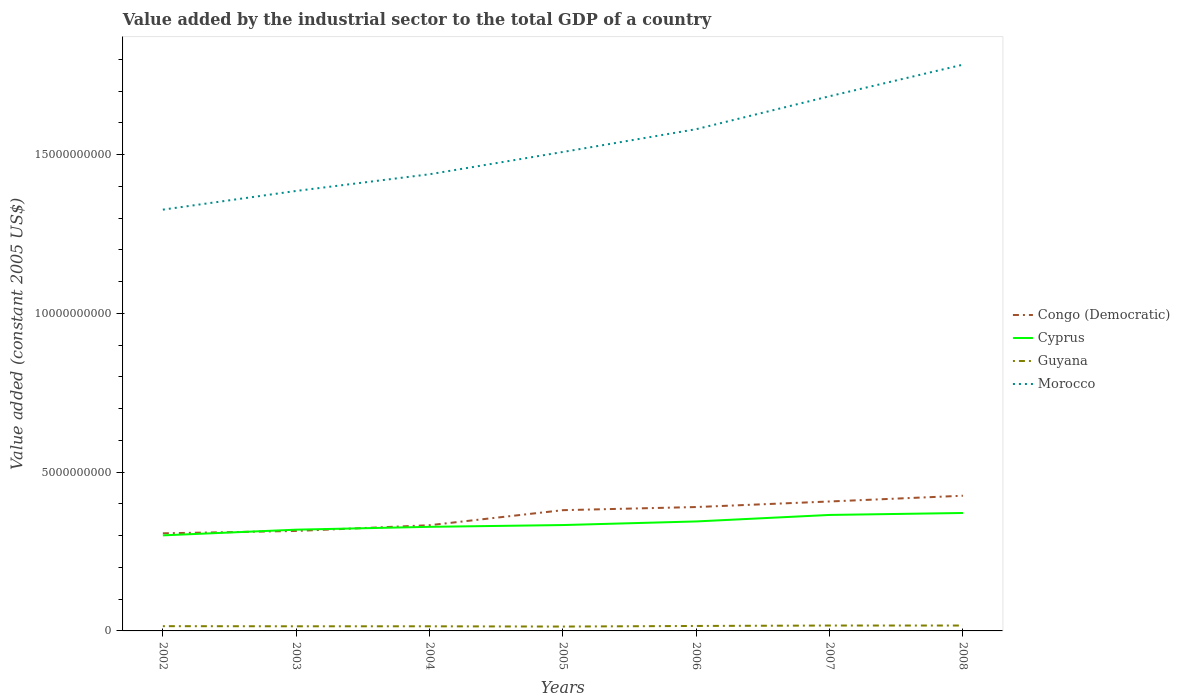How many different coloured lines are there?
Ensure brevity in your answer.  4. Across all years, what is the maximum value added by the industrial sector in Morocco?
Offer a very short reply. 1.33e+1. What is the total value added by the industrial sector in Cyprus in the graph?
Provide a short and direct response. -1.79e+08. What is the difference between the highest and the second highest value added by the industrial sector in Congo (Democratic)?
Offer a terse response. 1.18e+09. Is the value added by the industrial sector in Morocco strictly greater than the value added by the industrial sector in Congo (Democratic) over the years?
Offer a terse response. No. How many years are there in the graph?
Provide a succinct answer. 7. What is the difference between two consecutive major ticks on the Y-axis?
Provide a short and direct response. 5.00e+09. Does the graph contain any zero values?
Your response must be concise. No. Where does the legend appear in the graph?
Provide a succinct answer. Center right. What is the title of the graph?
Ensure brevity in your answer.  Value added by the industrial sector to the total GDP of a country. What is the label or title of the Y-axis?
Provide a succinct answer. Value added (constant 2005 US$). What is the Value added (constant 2005 US$) of Congo (Democratic) in 2002?
Offer a very short reply. 3.07e+09. What is the Value added (constant 2005 US$) in Cyprus in 2002?
Ensure brevity in your answer.  3.01e+09. What is the Value added (constant 2005 US$) of Guyana in 2002?
Your answer should be very brief. 1.50e+08. What is the Value added (constant 2005 US$) of Morocco in 2002?
Offer a very short reply. 1.33e+1. What is the Value added (constant 2005 US$) of Congo (Democratic) in 2003?
Your answer should be very brief. 3.15e+09. What is the Value added (constant 2005 US$) of Cyprus in 2003?
Your answer should be very brief. 3.19e+09. What is the Value added (constant 2005 US$) in Guyana in 2003?
Provide a short and direct response. 1.46e+08. What is the Value added (constant 2005 US$) of Morocco in 2003?
Provide a short and direct response. 1.39e+1. What is the Value added (constant 2005 US$) of Congo (Democratic) in 2004?
Provide a short and direct response. 3.33e+09. What is the Value added (constant 2005 US$) in Cyprus in 2004?
Provide a succinct answer. 3.28e+09. What is the Value added (constant 2005 US$) in Guyana in 2004?
Make the answer very short. 1.45e+08. What is the Value added (constant 2005 US$) of Morocco in 2004?
Provide a short and direct response. 1.44e+1. What is the Value added (constant 2005 US$) in Congo (Democratic) in 2005?
Offer a terse response. 3.80e+09. What is the Value added (constant 2005 US$) in Cyprus in 2005?
Keep it short and to the point. 3.34e+09. What is the Value added (constant 2005 US$) of Guyana in 2005?
Keep it short and to the point. 1.38e+08. What is the Value added (constant 2005 US$) in Morocco in 2005?
Ensure brevity in your answer.  1.51e+1. What is the Value added (constant 2005 US$) in Congo (Democratic) in 2006?
Provide a succinct answer. 3.90e+09. What is the Value added (constant 2005 US$) in Cyprus in 2006?
Your answer should be very brief. 3.45e+09. What is the Value added (constant 2005 US$) in Guyana in 2006?
Keep it short and to the point. 1.56e+08. What is the Value added (constant 2005 US$) of Morocco in 2006?
Offer a terse response. 1.58e+1. What is the Value added (constant 2005 US$) in Congo (Democratic) in 2007?
Offer a terse response. 4.08e+09. What is the Value added (constant 2005 US$) of Cyprus in 2007?
Offer a terse response. 3.65e+09. What is the Value added (constant 2005 US$) in Guyana in 2007?
Make the answer very short. 1.70e+08. What is the Value added (constant 2005 US$) of Morocco in 2007?
Your answer should be very brief. 1.68e+1. What is the Value added (constant 2005 US$) in Congo (Democratic) in 2008?
Make the answer very short. 4.26e+09. What is the Value added (constant 2005 US$) of Cyprus in 2008?
Give a very brief answer. 3.72e+09. What is the Value added (constant 2005 US$) of Guyana in 2008?
Provide a succinct answer. 1.70e+08. What is the Value added (constant 2005 US$) in Morocco in 2008?
Offer a terse response. 1.78e+1. Across all years, what is the maximum Value added (constant 2005 US$) of Congo (Democratic)?
Your answer should be very brief. 4.26e+09. Across all years, what is the maximum Value added (constant 2005 US$) in Cyprus?
Make the answer very short. 3.72e+09. Across all years, what is the maximum Value added (constant 2005 US$) of Guyana?
Keep it short and to the point. 1.70e+08. Across all years, what is the maximum Value added (constant 2005 US$) in Morocco?
Keep it short and to the point. 1.78e+1. Across all years, what is the minimum Value added (constant 2005 US$) in Congo (Democratic)?
Your response must be concise. 3.07e+09. Across all years, what is the minimum Value added (constant 2005 US$) of Cyprus?
Keep it short and to the point. 3.01e+09. Across all years, what is the minimum Value added (constant 2005 US$) of Guyana?
Your answer should be very brief. 1.38e+08. Across all years, what is the minimum Value added (constant 2005 US$) in Morocco?
Give a very brief answer. 1.33e+1. What is the total Value added (constant 2005 US$) in Congo (Democratic) in the graph?
Offer a terse response. 2.56e+1. What is the total Value added (constant 2005 US$) of Cyprus in the graph?
Provide a short and direct response. 2.36e+1. What is the total Value added (constant 2005 US$) in Guyana in the graph?
Provide a succinct answer. 1.07e+09. What is the total Value added (constant 2005 US$) of Morocco in the graph?
Offer a terse response. 1.07e+11. What is the difference between the Value added (constant 2005 US$) of Congo (Democratic) in 2002 and that in 2003?
Keep it short and to the point. -7.45e+07. What is the difference between the Value added (constant 2005 US$) of Cyprus in 2002 and that in 2003?
Keep it short and to the point. -1.79e+08. What is the difference between the Value added (constant 2005 US$) of Guyana in 2002 and that in 2003?
Give a very brief answer. 4.14e+06. What is the difference between the Value added (constant 2005 US$) of Morocco in 2002 and that in 2003?
Keep it short and to the point. -5.89e+08. What is the difference between the Value added (constant 2005 US$) of Congo (Democratic) in 2002 and that in 2004?
Your answer should be very brief. -2.56e+08. What is the difference between the Value added (constant 2005 US$) of Cyprus in 2002 and that in 2004?
Provide a short and direct response. -2.69e+08. What is the difference between the Value added (constant 2005 US$) in Guyana in 2002 and that in 2004?
Your response must be concise. 4.43e+06. What is the difference between the Value added (constant 2005 US$) in Morocco in 2002 and that in 2004?
Ensure brevity in your answer.  -1.11e+09. What is the difference between the Value added (constant 2005 US$) of Congo (Democratic) in 2002 and that in 2005?
Your answer should be very brief. -7.29e+08. What is the difference between the Value added (constant 2005 US$) of Cyprus in 2002 and that in 2005?
Your answer should be compact. -3.25e+08. What is the difference between the Value added (constant 2005 US$) of Guyana in 2002 and that in 2005?
Offer a very short reply. 1.24e+07. What is the difference between the Value added (constant 2005 US$) in Morocco in 2002 and that in 2005?
Your answer should be very brief. -1.82e+09. What is the difference between the Value added (constant 2005 US$) of Congo (Democratic) in 2002 and that in 2006?
Your answer should be compact. -8.28e+08. What is the difference between the Value added (constant 2005 US$) of Cyprus in 2002 and that in 2006?
Offer a terse response. -4.38e+08. What is the difference between the Value added (constant 2005 US$) in Guyana in 2002 and that in 2006?
Give a very brief answer. -6.51e+06. What is the difference between the Value added (constant 2005 US$) in Morocco in 2002 and that in 2006?
Provide a succinct answer. -2.53e+09. What is the difference between the Value added (constant 2005 US$) in Congo (Democratic) in 2002 and that in 2007?
Your answer should be compact. -1.00e+09. What is the difference between the Value added (constant 2005 US$) in Cyprus in 2002 and that in 2007?
Keep it short and to the point. -6.43e+08. What is the difference between the Value added (constant 2005 US$) in Guyana in 2002 and that in 2007?
Provide a short and direct response. -1.97e+07. What is the difference between the Value added (constant 2005 US$) in Morocco in 2002 and that in 2007?
Ensure brevity in your answer.  -3.57e+09. What is the difference between the Value added (constant 2005 US$) of Congo (Democratic) in 2002 and that in 2008?
Make the answer very short. -1.18e+09. What is the difference between the Value added (constant 2005 US$) of Cyprus in 2002 and that in 2008?
Your answer should be very brief. -7.05e+08. What is the difference between the Value added (constant 2005 US$) of Guyana in 2002 and that in 2008?
Provide a succinct answer. -2.00e+07. What is the difference between the Value added (constant 2005 US$) of Morocco in 2002 and that in 2008?
Make the answer very short. -4.57e+09. What is the difference between the Value added (constant 2005 US$) in Congo (Democratic) in 2003 and that in 2004?
Provide a short and direct response. -1.81e+08. What is the difference between the Value added (constant 2005 US$) of Cyprus in 2003 and that in 2004?
Make the answer very short. -8.94e+07. What is the difference between the Value added (constant 2005 US$) of Guyana in 2003 and that in 2004?
Your answer should be very brief. 2.94e+05. What is the difference between the Value added (constant 2005 US$) in Morocco in 2003 and that in 2004?
Provide a succinct answer. -5.25e+08. What is the difference between the Value added (constant 2005 US$) in Congo (Democratic) in 2003 and that in 2005?
Your answer should be compact. -6.55e+08. What is the difference between the Value added (constant 2005 US$) in Cyprus in 2003 and that in 2005?
Give a very brief answer. -1.46e+08. What is the difference between the Value added (constant 2005 US$) in Guyana in 2003 and that in 2005?
Ensure brevity in your answer.  8.24e+06. What is the difference between the Value added (constant 2005 US$) of Morocco in 2003 and that in 2005?
Your response must be concise. -1.23e+09. What is the difference between the Value added (constant 2005 US$) of Congo (Democratic) in 2003 and that in 2006?
Your answer should be compact. -7.54e+08. What is the difference between the Value added (constant 2005 US$) in Cyprus in 2003 and that in 2006?
Offer a terse response. -2.59e+08. What is the difference between the Value added (constant 2005 US$) in Guyana in 2003 and that in 2006?
Ensure brevity in your answer.  -1.07e+07. What is the difference between the Value added (constant 2005 US$) in Morocco in 2003 and that in 2006?
Your answer should be compact. -1.95e+09. What is the difference between the Value added (constant 2005 US$) in Congo (Democratic) in 2003 and that in 2007?
Your response must be concise. -9.29e+08. What is the difference between the Value added (constant 2005 US$) of Cyprus in 2003 and that in 2007?
Ensure brevity in your answer.  -4.64e+08. What is the difference between the Value added (constant 2005 US$) of Guyana in 2003 and that in 2007?
Make the answer very short. -2.39e+07. What is the difference between the Value added (constant 2005 US$) of Morocco in 2003 and that in 2007?
Provide a short and direct response. -2.98e+09. What is the difference between the Value added (constant 2005 US$) in Congo (Democratic) in 2003 and that in 2008?
Your response must be concise. -1.11e+09. What is the difference between the Value added (constant 2005 US$) in Cyprus in 2003 and that in 2008?
Your answer should be compact. -5.26e+08. What is the difference between the Value added (constant 2005 US$) of Guyana in 2003 and that in 2008?
Provide a succinct answer. -2.41e+07. What is the difference between the Value added (constant 2005 US$) of Morocco in 2003 and that in 2008?
Your answer should be compact. -3.98e+09. What is the difference between the Value added (constant 2005 US$) of Congo (Democratic) in 2004 and that in 2005?
Your answer should be compact. -4.74e+08. What is the difference between the Value added (constant 2005 US$) of Cyprus in 2004 and that in 2005?
Your response must be concise. -5.62e+07. What is the difference between the Value added (constant 2005 US$) of Guyana in 2004 and that in 2005?
Ensure brevity in your answer.  7.95e+06. What is the difference between the Value added (constant 2005 US$) of Morocco in 2004 and that in 2005?
Provide a succinct answer. -7.02e+08. What is the difference between the Value added (constant 2005 US$) of Congo (Democratic) in 2004 and that in 2006?
Your response must be concise. -5.73e+08. What is the difference between the Value added (constant 2005 US$) in Cyprus in 2004 and that in 2006?
Ensure brevity in your answer.  -1.70e+08. What is the difference between the Value added (constant 2005 US$) in Guyana in 2004 and that in 2006?
Your response must be concise. -1.09e+07. What is the difference between the Value added (constant 2005 US$) in Morocco in 2004 and that in 2006?
Your answer should be very brief. -1.42e+09. What is the difference between the Value added (constant 2005 US$) in Congo (Democratic) in 2004 and that in 2007?
Keep it short and to the point. -7.47e+08. What is the difference between the Value added (constant 2005 US$) of Cyprus in 2004 and that in 2007?
Make the answer very short. -3.75e+08. What is the difference between the Value added (constant 2005 US$) of Guyana in 2004 and that in 2007?
Offer a terse response. -2.42e+07. What is the difference between the Value added (constant 2005 US$) of Morocco in 2004 and that in 2007?
Offer a terse response. -2.46e+09. What is the difference between the Value added (constant 2005 US$) of Congo (Democratic) in 2004 and that in 2008?
Make the answer very short. -9.29e+08. What is the difference between the Value added (constant 2005 US$) of Cyprus in 2004 and that in 2008?
Your answer should be very brief. -4.36e+08. What is the difference between the Value added (constant 2005 US$) in Guyana in 2004 and that in 2008?
Your answer should be compact. -2.44e+07. What is the difference between the Value added (constant 2005 US$) of Morocco in 2004 and that in 2008?
Make the answer very short. -3.45e+09. What is the difference between the Value added (constant 2005 US$) of Congo (Democratic) in 2005 and that in 2006?
Provide a short and direct response. -9.88e+07. What is the difference between the Value added (constant 2005 US$) of Cyprus in 2005 and that in 2006?
Provide a short and direct response. -1.14e+08. What is the difference between the Value added (constant 2005 US$) in Guyana in 2005 and that in 2006?
Ensure brevity in your answer.  -1.89e+07. What is the difference between the Value added (constant 2005 US$) of Morocco in 2005 and that in 2006?
Give a very brief answer. -7.18e+08. What is the difference between the Value added (constant 2005 US$) of Congo (Democratic) in 2005 and that in 2007?
Give a very brief answer. -2.74e+08. What is the difference between the Value added (constant 2005 US$) of Cyprus in 2005 and that in 2007?
Ensure brevity in your answer.  -3.19e+08. What is the difference between the Value added (constant 2005 US$) in Guyana in 2005 and that in 2007?
Your answer should be very brief. -3.21e+07. What is the difference between the Value added (constant 2005 US$) in Morocco in 2005 and that in 2007?
Make the answer very short. -1.76e+09. What is the difference between the Value added (constant 2005 US$) of Congo (Democratic) in 2005 and that in 2008?
Your answer should be very brief. -4.55e+08. What is the difference between the Value added (constant 2005 US$) in Cyprus in 2005 and that in 2008?
Provide a succinct answer. -3.80e+08. What is the difference between the Value added (constant 2005 US$) of Guyana in 2005 and that in 2008?
Your response must be concise. -3.24e+07. What is the difference between the Value added (constant 2005 US$) of Morocco in 2005 and that in 2008?
Give a very brief answer. -2.75e+09. What is the difference between the Value added (constant 2005 US$) in Congo (Democratic) in 2006 and that in 2007?
Offer a terse response. -1.75e+08. What is the difference between the Value added (constant 2005 US$) of Cyprus in 2006 and that in 2007?
Provide a short and direct response. -2.05e+08. What is the difference between the Value added (constant 2005 US$) in Guyana in 2006 and that in 2007?
Give a very brief answer. -1.32e+07. What is the difference between the Value added (constant 2005 US$) of Morocco in 2006 and that in 2007?
Provide a succinct answer. -1.04e+09. What is the difference between the Value added (constant 2005 US$) in Congo (Democratic) in 2006 and that in 2008?
Keep it short and to the point. -3.56e+08. What is the difference between the Value added (constant 2005 US$) of Cyprus in 2006 and that in 2008?
Provide a succinct answer. -2.66e+08. What is the difference between the Value added (constant 2005 US$) of Guyana in 2006 and that in 2008?
Give a very brief answer. -1.35e+07. What is the difference between the Value added (constant 2005 US$) of Morocco in 2006 and that in 2008?
Your response must be concise. -2.03e+09. What is the difference between the Value added (constant 2005 US$) of Congo (Democratic) in 2007 and that in 2008?
Give a very brief answer. -1.81e+08. What is the difference between the Value added (constant 2005 US$) in Cyprus in 2007 and that in 2008?
Your response must be concise. -6.15e+07. What is the difference between the Value added (constant 2005 US$) of Guyana in 2007 and that in 2008?
Provide a succinct answer. -2.52e+05. What is the difference between the Value added (constant 2005 US$) in Morocco in 2007 and that in 2008?
Your answer should be very brief. -9.94e+08. What is the difference between the Value added (constant 2005 US$) of Congo (Democratic) in 2002 and the Value added (constant 2005 US$) of Cyprus in 2003?
Keep it short and to the point. -1.15e+08. What is the difference between the Value added (constant 2005 US$) of Congo (Democratic) in 2002 and the Value added (constant 2005 US$) of Guyana in 2003?
Offer a very short reply. 2.93e+09. What is the difference between the Value added (constant 2005 US$) of Congo (Democratic) in 2002 and the Value added (constant 2005 US$) of Morocco in 2003?
Offer a very short reply. -1.08e+1. What is the difference between the Value added (constant 2005 US$) in Cyprus in 2002 and the Value added (constant 2005 US$) in Guyana in 2003?
Give a very brief answer. 2.86e+09. What is the difference between the Value added (constant 2005 US$) of Cyprus in 2002 and the Value added (constant 2005 US$) of Morocco in 2003?
Your response must be concise. -1.08e+1. What is the difference between the Value added (constant 2005 US$) in Guyana in 2002 and the Value added (constant 2005 US$) in Morocco in 2003?
Your answer should be very brief. -1.37e+1. What is the difference between the Value added (constant 2005 US$) of Congo (Democratic) in 2002 and the Value added (constant 2005 US$) of Cyprus in 2004?
Your response must be concise. -2.04e+08. What is the difference between the Value added (constant 2005 US$) in Congo (Democratic) in 2002 and the Value added (constant 2005 US$) in Guyana in 2004?
Provide a short and direct response. 2.93e+09. What is the difference between the Value added (constant 2005 US$) of Congo (Democratic) in 2002 and the Value added (constant 2005 US$) of Morocco in 2004?
Make the answer very short. -1.13e+1. What is the difference between the Value added (constant 2005 US$) in Cyprus in 2002 and the Value added (constant 2005 US$) in Guyana in 2004?
Provide a short and direct response. 2.86e+09. What is the difference between the Value added (constant 2005 US$) of Cyprus in 2002 and the Value added (constant 2005 US$) of Morocco in 2004?
Give a very brief answer. -1.14e+1. What is the difference between the Value added (constant 2005 US$) of Guyana in 2002 and the Value added (constant 2005 US$) of Morocco in 2004?
Make the answer very short. -1.42e+1. What is the difference between the Value added (constant 2005 US$) of Congo (Democratic) in 2002 and the Value added (constant 2005 US$) of Cyprus in 2005?
Ensure brevity in your answer.  -2.61e+08. What is the difference between the Value added (constant 2005 US$) of Congo (Democratic) in 2002 and the Value added (constant 2005 US$) of Guyana in 2005?
Make the answer very short. 2.94e+09. What is the difference between the Value added (constant 2005 US$) in Congo (Democratic) in 2002 and the Value added (constant 2005 US$) in Morocco in 2005?
Ensure brevity in your answer.  -1.20e+1. What is the difference between the Value added (constant 2005 US$) of Cyprus in 2002 and the Value added (constant 2005 US$) of Guyana in 2005?
Provide a succinct answer. 2.87e+09. What is the difference between the Value added (constant 2005 US$) in Cyprus in 2002 and the Value added (constant 2005 US$) in Morocco in 2005?
Provide a succinct answer. -1.21e+1. What is the difference between the Value added (constant 2005 US$) in Guyana in 2002 and the Value added (constant 2005 US$) in Morocco in 2005?
Your answer should be very brief. -1.49e+1. What is the difference between the Value added (constant 2005 US$) of Congo (Democratic) in 2002 and the Value added (constant 2005 US$) of Cyprus in 2006?
Provide a short and direct response. -3.74e+08. What is the difference between the Value added (constant 2005 US$) in Congo (Democratic) in 2002 and the Value added (constant 2005 US$) in Guyana in 2006?
Provide a succinct answer. 2.92e+09. What is the difference between the Value added (constant 2005 US$) in Congo (Democratic) in 2002 and the Value added (constant 2005 US$) in Morocco in 2006?
Offer a very short reply. -1.27e+1. What is the difference between the Value added (constant 2005 US$) of Cyprus in 2002 and the Value added (constant 2005 US$) of Guyana in 2006?
Provide a succinct answer. 2.85e+09. What is the difference between the Value added (constant 2005 US$) in Cyprus in 2002 and the Value added (constant 2005 US$) in Morocco in 2006?
Keep it short and to the point. -1.28e+1. What is the difference between the Value added (constant 2005 US$) of Guyana in 2002 and the Value added (constant 2005 US$) of Morocco in 2006?
Give a very brief answer. -1.57e+1. What is the difference between the Value added (constant 2005 US$) of Congo (Democratic) in 2002 and the Value added (constant 2005 US$) of Cyprus in 2007?
Offer a terse response. -5.79e+08. What is the difference between the Value added (constant 2005 US$) of Congo (Democratic) in 2002 and the Value added (constant 2005 US$) of Guyana in 2007?
Give a very brief answer. 2.90e+09. What is the difference between the Value added (constant 2005 US$) in Congo (Democratic) in 2002 and the Value added (constant 2005 US$) in Morocco in 2007?
Your answer should be very brief. -1.38e+1. What is the difference between the Value added (constant 2005 US$) in Cyprus in 2002 and the Value added (constant 2005 US$) in Guyana in 2007?
Offer a very short reply. 2.84e+09. What is the difference between the Value added (constant 2005 US$) in Cyprus in 2002 and the Value added (constant 2005 US$) in Morocco in 2007?
Ensure brevity in your answer.  -1.38e+1. What is the difference between the Value added (constant 2005 US$) in Guyana in 2002 and the Value added (constant 2005 US$) in Morocco in 2007?
Keep it short and to the point. -1.67e+1. What is the difference between the Value added (constant 2005 US$) of Congo (Democratic) in 2002 and the Value added (constant 2005 US$) of Cyprus in 2008?
Your answer should be compact. -6.41e+08. What is the difference between the Value added (constant 2005 US$) of Congo (Democratic) in 2002 and the Value added (constant 2005 US$) of Guyana in 2008?
Your response must be concise. 2.90e+09. What is the difference between the Value added (constant 2005 US$) in Congo (Democratic) in 2002 and the Value added (constant 2005 US$) in Morocco in 2008?
Keep it short and to the point. -1.48e+1. What is the difference between the Value added (constant 2005 US$) in Cyprus in 2002 and the Value added (constant 2005 US$) in Guyana in 2008?
Make the answer very short. 2.84e+09. What is the difference between the Value added (constant 2005 US$) in Cyprus in 2002 and the Value added (constant 2005 US$) in Morocco in 2008?
Offer a terse response. -1.48e+1. What is the difference between the Value added (constant 2005 US$) in Guyana in 2002 and the Value added (constant 2005 US$) in Morocco in 2008?
Your response must be concise. -1.77e+1. What is the difference between the Value added (constant 2005 US$) in Congo (Democratic) in 2003 and the Value added (constant 2005 US$) in Cyprus in 2004?
Ensure brevity in your answer.  -1.30e+08. What is the difference between the Value added (constant 2005 US$) in Congo (Democratic) in 2003 and the Value added (constant 2005 US$) in Guyana in 2004?
Offer a terse response. 3.00e+09. What is the difference between the Value added (constant 2005 US$) in Congo (Democratic) in 2003 and the Value added (constant 2005 US$) in Morocco in 2004?
Ensure brevity in your answer.  -1.12e+1. What is the difference between the Value added (constant 2005 US$) of Cyprus in 2003 and the Value added (constant 2005 US$) of Guyana in 2004?
Provide a short and direct response. 3.04e+09. What is the difference between the Value added (constant 2005 US$) of Cyprus in 2003 and the Value added (constant 2005 US$) of Morocco in 2004?
Make the answer very short. -1.12e+1. What is the difference between the Value added (constant 2005 US$) of Guyana in 2003 and the Value added (constant 2005 US$) of Morocco in 2004?
Offer a terse response. -1.42e+1. What is the difference between the Value added (constant 2005 US$) in Congo (Democratic) in 2003 and the Value added (constant 2005 US$) in Cyprus in 2005?
Keep it short and to the point. -1.86e+08. What is the difference between the Value added (constant 2005 US$) in Congo (Democratic) in 2003 and the Value added (constant 2005 US$) in Guyana in 2005?
Your answer should be very brief. 3.01e+09. What is the difference between the Value added (constant 2005 US$) of Congo (Democratic) in 2003 and the Value added (constant 2005 US$) of Morocco in 2005?
Your answer should be compact. -1.19e+1. What is the difference between the Value added (constant 2005 US$) of Cyprus in 2003 and the Value added (constant 2005 US$) of Guyana in 2005?
Provide a short and direct response. 3.05e+09. What is the difference between the Value added (constant 2005 US$) in Cyprus in 2003 and the Value added (constant 2005 US$) in Morocco in 2005?
Your response must be concise. -1.19e+1. What is the difference between the Value added (constant 2005 US$) in Guyana in 2003 and the Value added (constant 2005 US$) in Morocco in 2005?
Your answer should be very brief. -1.49e+1. What is the difference between the Value added (constant 2005 US$) in Congo (Democratic) in 2003 and the Value added (constant 2005 US$) in Cyprus in 2006?
Your answer should be very brief. -3.00e+08. What is the difference between the Value added (constant 2005 US$) of Congo (Democratic) in 2003 and the Value added (constant 2005 US$) of Guyana in 2006?
Make the answer very short. 2.99e+09. What is the difference between the Value added (constant 2005 US$) of Congo (Democratic) in 2003 and the Value added (constant 2005 US$) of Morocco in 2006?
Provide a succinct answer. -1.27e+1. What is the difference between the Value added (constant 2005 US$) in Cyprus in 2003 and the Value added (constant 2005 US$) in Guyana in 2006?
Keep it short and to the point. 3.03e+09. What is the difference between the Value added (constant 2005 US$) in Cyprus in 2003 and the Value added (constant 2005 US$) in Morocco in 2006?
Your answer should be compact. -1.26e+1. What is the difference between the Value added (constant 2005 US$) in Guyana in 2003 and the Value added (constant 2005 US$) in Morocco in 2006?
Give a very brief answer. -1.57e+1. What is the difference between the Value added (constant 2005 US$) of Congo (Democratic) in 2003 and the Value added (constant 2005 US$) of Cyprus in 2007?
Give a very brief answer. -5.05e+08. What is the difference between the Value added (constant 2005 US$) in Congo (Democratic) in 2003 and the Value added (constant 2005 US$) in Guyana in 2007?
Provide a short and direct response. 2.98e+09. What is the difference between the Value added (constant 2005 US$) of Congo (Democratic) in 2003 and the Value added (constant 2005 US$) of Morocco in 2007?
Give a very brief answer. -1.37e+1. What is the difference between the Value added (constant 2005 US$) of Cyprus in 2003 and the Value added (constant 2005 US$) of Guyana in 2007?
Offer a terse response. 3.02e+09. What is the difference between the Value added (constant 2005 US$) of Cyprus in 2003 and the Value added (constant 2005 US$) of Morocco in 2007?
Ensure brevity in your answer.  -1.37e+1. What is the difference between the Value added (constant 2005 US$) of Guyana in 2003 and the Value added (constant 2005 US$) of Morocco in 2007?
Give a very brief answer. -1.67e+1. What is the difference between the Value added (constant 2005 US$) in Congo (Democratic) in 2003 and the Value added (constant 2005 US$) in Cyprus in 2008?
Your answer should be very brief. -5.66e+08. What is the difference between the Value added (constant 2005 US$) in Congo (Democratic) in 2003 and the Value added (constant 2005 US$) in Guyana in 2008?
Your answer should be compact. 2.98e+09. What is the difference between the Value added (constant 2005 US$) of Congo (Democratic) in 2003 and the Value added (constant 2005 US$) of Morocco in 2008?
Your answer should be compact. -1.47e+1. What is the difference between the Value added (constant 2005 US$) of Cyprus in 2003 and the Value added (constant 2005 US$) of Guyana in 2008?
Your answer should be compact. 3.02e+09. What is the difference between the Value added (constant 2005 US$) in Cyprus in 2003 and the Value added (constant 2005 US$) in Morocco in 2008?
Keep it short and to the point. -1.46e+1. What is the difference between the Value added (constant 2005 US$) in Guyana in 2003 and the Value added (constant 2005 US$) in Morocco in 2008?
Provide a succinct answer. -1.77e+1. What is the difference between the Value added (constant 2005 US$) in Congo (Democratic) in 2004 and the Value added (constant 2005 US$) in Cyprus in 2005?
Your response must be concise. -5.15e+06. What is the difference between the Value added (constant 2005 US$) in Congo (Democratic) in 2004 and the Value added (constant 2005 US$) in Guyana in 2005?
Your response must be concise. 3.19e+09. What is the difference between the Value added (constant 2005 US$) of Congo (Democratic) in 2004 and the Value added (constant 2005 US$) of Morocco in 2005?
Make the answer very short. -1.18e+1. What is the difference between the Value added (constant 2005 US$) of Cyprus in 2004 and the Value added (constant 2005 US$) of Guyana in 2005?
Your response must be concise. 3.14e+09. What is the difference between the Value added (constant 2005 US$) of Cyprus in 2004 and the Value added (constant 2005 US$) of Morocco in 2005?
Your response must be concise. -1.18e+1. What is the difference between the Value added (constant 2005 US$) in Guyana in 2004 and the Value added (constant 2005 US$) in Morocco in 2005?
Ensure brevity in your answer.  -1.49e+1. What is the difference between the Value added (constant 2005 US$) of Congo (Democratic) in 2004 and the Value added (constant 2005 US$) of Cyprus in 2006?
Your answer should be compact. -1.19e+08. What is the difference between the Value added (constant 2005 US$) in Congo (Democratic) in 2004 and the Value added (constant 2005 US$) in Guyana in 2006?
Ensure brevity in your answer.  3.17e+09. What is the difference between the Value added (constant 2005 US$) of Congo (Democratic) in 2004 and the Value added (constant 2005 US$) of Morocco in 2006?
Keep it short and to the point. -1.25e+1. What is the difference between the Value added (constant 2005 US$) of Cyprus in 2004 and the Value added (constant 2005 US$) of Guyana in 2006?
Keep it short and to the point. 3.12e+09. What is the difference between the Value added (constant 2005 US$) of Cyprus in 2004 and the Value added (constant 2005 US$) of Morocco in 2006?
Your answer should be very brief. -1.25e+1. What is the difference between the Value added (constant 2005 US$) in Guyana in 2004 and the Value added (constant 2005 US$) in Morocco in 2006?
Give a very brief answer. -1.57e+1. What is the difference between the Value added (constant 2005 US$) of Congo (Democratic) in 2004 and the Value added (constant 2005 US$) of Cyprus in 2007?
Your response must be concise. -3.24e+08. What is the difference between the Value added (constant 2005 US$) of Congo (Democratic) in 2004 and the Value added (constant 2005 US$) of Guyana in 2007?
Keep it short and to the point. 3.16e+09. What is the difference between the Value added (constant 2005 US$) of Congo (Democratic) in 2004 and the Value added (constant 2005 US$) of Morocco in 2007?
Give a very brief answer. -1.35e+1. What is the difference between the Value added (constant 2005 US$) in Cyprus in 2004 and the Value added (constant 2005 US$) in Guyana in 2007?
Offer a terse response. 3.11e+09. What is the difference between the Value added (constant 2005 US$) of Cyprus in 2004 and the Value added (constant 2005 US$) of Morocco in 2007?
Provide a short and direct response. -1.36e+1. What is the difference between the Value added (constant 2005 US$) of Guyana in 2004 and the Value added (constant 2005 US$) of Morocco in 2007?
Offer a terse response. -1.67e+1. What is the difference between the Value added (constant 2005 US$) in Congo (Democratic) in 2004 and the Value added (constant 2005 US$) in Cyprus in 2008?
Your answer should be compact. -3.85e+08. What is the difference between the Value added (constant 2005 US$) of Congo (Democratic) in 2004 and the Value added (constant 2005 US$) of Guyana in 2008?
Offer a terse response. 3.16e+09. What is the difference between the Value added (constant 2005 US$) in Congo (Democratic) in 2004 and the Value added (constant 2005 US$) in Morocco in 2008?
Your response must be concise. -1.45e+1. What is the difference between the Value added (constant 2005 US$) of Cyprus in 2004 and the Value added (constant 2005 US$) of Guyana in 2008?
Provide a succinct answer. 3.11e+09. What is the difference between the Value added (constant 2005 US$) in Cyprus in 2004 and the Value added (constant 2005 US$) in Morocco in 2008?
Your answer should be compact. -1.46e+1. What is the difference between the Value added (constant 2005 US$) of Guyana in 2004 and the Value added (constant 2005 US$) of Morocco in 2008?
Provide a short and direct response. -1.77e+1. What is the difference between the Value added (constant 2005 US$) in Congo (Democratic) in 2005 and the Value added (constant 2005 US$) in Cyprus in 2006?
Provide a short and direct response. 3.55e+08. What is the difference between the Value added (constant 2005 US$) of Congo (Democratic) in 2005 and the Value added (constant 2005 US$) of Guyana in 2006?
Keep it short and to the point. 3.65e+09. What is the difference between the Value added (constant 2005 US$) of Congo (Democratic) in 2005 and the Value added (constant 2005 US$) of Morocco in 2006?
Your answer should be compact. -1.20e+1. What is the difference between the Value added (constant 2005 US$) of Cyprus in 2005 and the Value added (constant 2005 US$) of Guyana in 2006?
Provide a succinct answer. 3.18e+09. What is the difference between the Value added (constant 2005 US$) of Cyprus in 2005 and the Value added (constant 2005 US$) of Morocco in 2006?
Make the answer very short. -1.25e+1. What is the difference between the Value added (constant 2005 US$) of Guyana in 2005 and the Value added (constant 2005 US$) of Morocco in 2006?
Ensure brevity in your answer.  -1.57e+1. What is the difference between the Value added (constant 2005 US$) of Congo (Democratic) in 2005 and the Value added (constant 2005 US$) of Cyprus in 2007?
Your response must be concise. 1.50e+08. What is the difference between the Value added (constant 2005 US$) in Congo (Democratic) in 2005 and the Value added (constant 2005 US$) in Guyana in 2007?
Make the answer very short. 3.63e+09. What is the difference between the Value added (constant 2005 US$) of Congo (Democratic) in 2005 and the Value added (constant 2005 US$) of Morocco in 2007?
Offer a terse response. -1.30e+1. What is the difference between the Value added (constant 2005 US$) of Cyprus in 2005 and the Value added (constant 2005 US$) of Guyana in 2007?
Your response must be concise. 3.17e+09. What is the difference between the Value added (constant 2005 US$) in Cyprus in 2005 and the Value added (constant 2005 US$) in Morocco in 2007?
Provide a succinct answer. -1.35e+1. What is the difference between the Value added (constant 2005 US$) of Guyana in 2005 and the Value added (constant 2005 US$) of Morocco in 2007?
Provide a succinct answer. -1.67e+1. What is the difference between the Value added (constant 2005 US$) in Congo (Democratic) in 2005 and the Value added (constant 2005 US$) in Cyprus in 2008?
Keep it short and to the point. 8.85e+07. What is the difference between the Value added (constant 2005 US$) in Congo (Democratic) in 2005 and the Value added (constant 2005 US$) in Guyana in 2008?
Your answer should be very brief. 3.63e+09. What is the difference between the Value added (constant 2005 US$) of Congo (Democratic) in 2005 and the Value added (constant 2005 US$) of Morocco in 2008?
Keep it short and to the point. -1.40e+1. What is the difference between the Value added (constant 2005 US$) in Cyprus in 2005 and the Value added (constant 2005 US$) in Guyana in 2008?
Your answer should be very brief. 3.17e+09. What is the difference between the Value added (constant 2005 US$) of Cyprus in 2005 and the Value added (constant 2005 US$) of Morocco in 2008?
Keep it short and to the point. -1.45e+1. What is the difference between the Value added (constant 2005 US$) in Guyana in 2005 and the Value added (constant 2005 US$) in Morocco in 2008?
Provide a succinct answer. -1.77e+1. What is the difference between the Value added (constant 2005 US$) of Congo (Democratic) in 2006 and the Value added (constant 2005 US$) of Cyprus in 2007?
Offer a terse response. 2.49e+08. What is the difference between the Value added (constant 2005 US$) of Congo (Democratic) in 2006 and the Value added (constant 2005 US$) of Guyana in 2007?
Your response must be concise. 3.73e+09. What is the difference between the Value added (constant 2005 US$) in Congo (Democratic) in 2006 and the Value added (constant 2005 US$) in Morocco in 2007?
Your response must be concise. -1.29e+1. What is the difference between the Value added (constant 2005 US$) in Cyprus in 2006 and the Value added (constant 2005 US$) in Guyana in 2007?
Make the answer very short. 3.28e+09. What is the difference between the Value added (constant 2005 US$) of Cyprus in 2006 and the Value added (constant 2005 US$) of Morocco in 2007?
Keep it short and to the point. -1.34e+1. What is the difference between the Value added (constant 2005 US$) of Guyana in 2006 and the Value added (constant 2005 US$) of Morocco in 2007?
Offer a very short reply. -1.67e+1. What is the difference between the Value added (constant 2005 US$) of Congo (Democratic) in 2006 and the Value added (constant 2005 US$) of Cyprus in 2008?
Your answer should be compact. 1.87e+08. What is the difference between the Value added (constant 2005 US$) in Congo (Democratic) in 2006 and the Value added (constant 2005 US$) in Guyana in 2008?
Offer a very short reply. 3.73e+09. What is the difference between the Value added (constant 2005 US$) of Congo (Democratic) in 2006 and the Value added (constant 2005 US$) of Morocco in 2008?
Your response must be concise. -1.39e+1. What is the difference between the Value added (constant 2005 US$) of Cyprus in 2006 and the Value added (constant 2005 US$) of Guyana in 2008?
Keep it short and to the point. 3.28e+09. What is the difference between the Value added (constant 2005 US$) in Cyprus in 2006 and the Value added (constant 2005 US$) in Morocco in 2008?
Make the answer very short. -1.44e+1. What is the difference between the Value added (constant 2005 US$) in Guyana in 2006 and the Value added (constant 2005 US$) in Morocco in 2008?
Provide a short and direct response. -1.77e+1. What is the difference between the Value added (constant 2005 US$) of Congo (Democratic) in 2007 and the Value added (constant 2005 US$) of Cyprus in 2008?
Provide a short and direct response. 3.62e+08. What is the difference between the Value added (constant 2005 US$) in Congo (Democratic) in 2007 and the Value added (constant 2005 US$) in Guyana in 2008?
Offer a very short reply. 3.91e+09. What is the difference between the Value added (constant 2005 US$) in Congo (Democratic) in 2007 and the Value added (constant 2005 US$) in Morocco in 2008?
Your answer should be compact. -1.38e+1. What is the difference between the Value added (constant 2005 US$) in Cyprus in 2007 and the Value added (constant 2005 US$) in Guyana in 2008?
Your answer should be compact. 3.48e+09. What is the difference between the Value added (constant 2005 US$) in Cyprus in 2007 and the Value added (constant 2005 US$) in Morocco in 2008?
Provide a succinct answer. -1.42e+1. What is the difference between the Value added (constant 2005 US$) of Guyana in 2007 and the Value added (constant 2005 US$) of Morocco in 2008?
Keep it short and to the point. -1.77e+1. What is the average Value added (constant 2005 US$) of Congo (Democratic) per year?
Offer a terse response. 3.66e+09. What is the average Value added (constant 2005 US$) of Cyprus per year?
Give a very brief answer. 3.38e+09. What is the average Value added (constant 2005 US$) of Guyana per year?
Make the answer very short. 1.53e+08. What is the average Value added (constant 2005 US$) in Morocco per year?
Give a very brief answer. 1.53e+1. In the year 2002, what is the difference between the Value added (constant 2005 US$) in Congo (Democratic) and Value added (constant 2005 US$) in Cyprus?
Ensure brevity in your answer.  6.42e+07. In the year 2002, what is the difference between the Value added (constant 2005 US$) of Congo (Democratic) and Value added (constant 2005 US$) of Guyana?
Your response must be concise. 2.92e+09. In the year 2002, what is the difference between the Value added (constant 2005 US$) in Congo (Democratic) and Value added (constant 2005 US$) in Morocco?
Your answer should be very brief. -1.02e+1. In the year 2002, what is the difference between the Value added (constant 2005 US$) of Cyprus and Value added (constant 2005 US$) of Guyana?
Make the answer very short. 2.86e+09. In the year 2002, what is the difference between the Value added (constant 2005 US$) of Cyprus and Value added (constant 2005 US$) of Morocco?
Provide a short and direct response. -1.03e+1. In the year 2002, what is the difference between the Value added (constant 2005 US$) in Guyana and Value added (constant 2005 US$) in Morocco?
Provide a short and direct response. -1.31e+1. In the year 2003, what is the difference between the Value added (constant 2005 US$) of Congo (Democratic) and Value added (constant 2005 US$) of Cyprus?
Provide a short and direct response. -4.06e+07. In the year 2003, what is the difference between the Value added (constant 2005 US$) in Congo (Democratic) and Value added (constant 2005 US$) in Guyana?
Provide a short and direct response. 3.00e+09. In the year 2003, what is the difference between the Value added (constant 2005 US$) in Congo (Democratic) and Value added (constant 2005 US$) in Morocco?
Your answer should be compact. -1.07e+1. In the year 2003, what is the difference between the Value added (constant 2005 US$) in Cyprus and Value added (constant 2005 US$) in Guyana?
Provide a short and direct response. 3.04e+09. In the year 2003, what is the difference between the Value added (constant 2005 US$) of Cyprus and Value added (constant 2005 US$) of Morocco?
Your answer should be very brief. -1.07e+1. In the year 2003, what is the difference between the Value added (constant 2005 US$) of Guyana and Value added (constant 2005 US$) of Morocco?
Your answer should be very brief. -1.37e+1. In the year 2004, what is the difference between the Value added (constant 2005 US$) in Congo (Democratic) and Value added (constant 2005 US$) in Cyprus?
Offer a terse response. 5.11e+07. In the year 2004, what is the difference between the Value added (constant 2005 US$) in Congo (Democratic) and Value added (constant 2005 US$) in Guyana?
Your answer should be very brief. 3.18e+09. In the year 2004, what is the difference between the Value added (constant 2005 US$) of Congo (Democratic) and Value added (constant 2005 US$) of Morocco?
Your answer should be very brief. -1.11e+1. In the year 2004, what is the difference between the Value added (constant 2005 US$) in Cyprus and Value added (constant 2005 US$) in Guyana?
Offer a very short reply. 3.13e+09. In the year 2004, what is the difference between the Value added (constant 2005 US$) of Cyprus and Value added (constant 2005 US$) of Morocco?
Keep it short and to the point. -1.11e+1. In the year 2004, what is the difference between the Value added (constant 2005 US$) in Guyana and Value added (constant 2005 US$) in Morocco?
Provide a succinct answer. -1.42e+1. In the year 2005, what is the difference between the Value added (constant 2005 US$) in Congo (Democratic) and Value added (constant 2005 US$) in Cyprus?
Ensure brevity in your answer.  4.69e+08. In the year 2005, what is the difference between the Value added (constant 2005 US$) in Congo (Democratic) and Value added (constant 2005 US$) in Guyana?
Offer a very short reply. 3.67e+09. In the year 2005, what is the difference between the Value added (constant 2005 US$) of Congo (Democratic) and Value added (constant 2005 US$) of Morocco?
Your answer should be very brief. -1.13e+1. In the year 2005, what is the difference between the Value added (constant 2005 US$) in Cyprus and Value added (constant 2005 US$) in Guyana?
Offer a very short reply. 3.20e+09. In the year 2005, what is the difference between the Value added (constant 2005 US$) in Cyprus and Value added (constant 2005 US$) in Morocco?
Offer a terse response. -1.18e+1. In the year 2005, what is the difference between the Value added (constant 2005 US$) of Guyana and Value added (constant 2005 US$) of Morocco?
Your response must be concise. -1.49e+1. In the year 2006, what is the difference between the Value added (constant 2005 US$) in Congo (Democratic) and Value added (constant 2005 US$) in Cyprus?
Keep it short and to the point. 4.54e+08. In the year 2006, what is the difference between the Value added (constant 2005 US$) in Congo (Democratic) and Value added (constant 2005 US$) in Guyana?
Offer a terse response. 3.75e+09. In the year 2006, what is the difference between the Value added (constant 2005 US$) in Congo (Democratic) and Value added (constant 2005 US$) in Morocco?
Give a very brief answer. -1.19e+1. In the year 2006, what is the difference between the Value added (constant 2005 US$) of Cyprus and Value added (constant 2005 US$) of Guyana?
Offer a terse response. 3.29e+09. In the year 2006, what is the difference between the Value added (constant 2005 US$) in Cyprus and Value added (constant 2005 US$) in Morocco?
Your answer should be very brief. -1.24e+1. In the year 2006, what is the difference between the Value added (constant 2005 US$) in Guyana and Value added (constant 2005 US$) in Morocco?
Ensure brevity in your answer.  -1.56e+1. In the year 2007, what is the difference between the Value added (constant 2005 US$) of Congo (Democratic) and Value added (constant 2005 US$) of Cyprus?
Your response must be concise. 4.24e+08. In the year 2007, what is the difference between the Value added (constant 2005 US$) of Congo (Democratic) and Value added (constant 2005 US$) of Guyana?
Your answer should be very brief. 3.91e+09. In the year 2007, what is the difference between the Value added (constant 2005 US$) in Congo (Democratic) and Value added (constant 2005 US$) in Morocco?
Your answer should be very brief. -1.28e+1. In the year 2007, what is the difference between the Value added (constant 2005 US$) in Cyprus and Value added (constant 2005 US$) in Guyana?
Offer a terse response. 3.48e+09. In the year 2007, what is the difference between the Value added (constant 2005 US$) of Cyprus and Value added (constant 2005 US$) of Morocco?
Your response must be concise. -1.32e+1. In the year 2007, what is the difference between the Value added (constant 2005 US$) of Guyana and Value added (constant 2005 US$) of Morocco?
Your answer should be compact. -1.67e+1. In the year 2008, what is the difference between the Value added (constant 2005 US$) in Congo (Democratic) and Value added (constant 2005 US$) in Cyprus?
Keep it short and to the point. 5.43e+08. In the year 2008, what is the difference between the Value added (constant 2005 US$) in Congo (Democratic) and Value added (constant 2005 US$) in Guyana?
Ensure brevity in your answer.  4.09e+09. In the year 2008, what is the difference between the Value added (constant 2005 US$) in Congo (Democratic) and Value added (constant 2005 US$) in Morocco?
Provide a succinct answer. -1.36e+1. In the year 2008, what is the difference between the Value added (constant 2005 US$) in Cyprus and Value added (constant 2005 US$) in Guyana?
Offer a terse response. 3.55e+09. In the year 2008, what is the difference between the Value added (constant 2005 US$) in Cyprus and Value added (constant 2005 US$) in Morocco?
Your answer should be very brief. -1.41e+1. In the year 2008, what is the difference between the Value added (constant 2005 US$) in Guyana and Value added (constant 2005 US$) in Morocco?
Provide a succinct answer. -1.77e+1. What is the ratio of the Value added (constant 2005 US$) in Congo (Democratic) in 2002 to that in 2003?
Offer a terse response. 0.98. What is the ratio of the Value added (constant 2005 US$) of Cyprus in 2002 to that in 2003?
Provide a short and direct response. 0.94. What is the ratio of the Value added (constant 2005 US$) in Guyana in 2002 to that in 2003?
Your answer should be very brief. 1.03. What is the ratio of the Value added (constant 2005 US$) of Morocco in 2002 to that in 2003?
Make the answer very short. 0.96. What is the ratio of the Value added (constant 2005 US$) of Congo (Democratic) in 2002 to that in 2004?
Offer a terse response. 0.92. What is the ratio of the Value added (constant 2005 US$) in Cyprus in 2002 to that in 2004?
Keep it short and to the point. 0.92. What is the ratio of the Value added (constant 2005 US$) of Guyana in 2002 to that in 2004?
Offer a very short reply. 1.03. What is the ratio of the Value added (constant 2005 US$) in Morocco in 2002 to that in 2004?
Your response must be concise. 0.92. What is the ratio of the Value added (constant 2005 US$) of Congo (Democratic) in 2002 to that in 2005?
Offer a very short reply. 0.81. What is the ratio of the Value added (constant 2005 US$) of Cyprus in 2002 to that in 2005?
Offer a very short reply. 0.9. What is the ratio of the Value added (constant 2005 US$) of Guyana in 2002 to that in 2005?
Offer a terse response. 1.09. What is the ratio of the Value added (constant 2005 US$) of Morocco in 2002 to that in 2005?
Keep it short and to the point. 0.88. What is the ratio of the Value added (constant 2005 US$) of Congo (Democratic) in 2002 to that in 2006?
Provide a short and direct response. 0.79. What is the ratio of the Value added (constant 2005 US$) of Cyprus in 2002 to that in 2006?
Offer a very short reply. 0.87. What is the ratio of the Value added (constant 2005 US$) in Morocco in 2002 to that in 2006?
Offer a terse response. 0.84. What is the ratio of the Value added (constant 2005 US$) in Congo (Democratic) in 2002 to that in 2007?
Keep it short and to the point. 0.75. What is the ratio of the Value added (constant 2005 US$) of Cyprus in 2002 to that in 2007?
Offer a very short reply. 0.82. What is the ratio of the Value added (constant 2005 US$) in Guyana in 2002 to that in 2007?
Your answer should be very brief. 0.88. What is the ratio of the Value added (constant 2005 US$) in Morocco in 2002 to that in 2007?
Ensure brevity in your answer.  0.79. What is the ratio of the Value added (constant 2005 US$) of Congo (Democratic) in 2002 to that in 2008?
Your answer should be very brief. 0.72. What is the ratio of the Value added (constant 2005 US$) of Cyprus in 2002 to that in 2008?
Provide a short and direct response. 0.81. What is the ratio of the Value added (constant 2005 US$) of Guyana in 2002 to that in 2008?
Your response must be concise. 0.88. What is the ratio of the Value added (constant 2005 US$) in Morocco in 2002 to that in 2008?
Keep it short and to the point. 0.74. What is the ratio of the Value added (constant 2005 US$) of Congo (Democratic) in 2003 to that in 2004?
Provide a short and direct response. 0.95. What is the ratio of the Value added (constant 2005 US$) in Cyprus in 2003 to that in 2004?
Ensure brevity in your answer.  0.97. What is the ratio of the Value added (constant 2005 US$) of Guyana in 2003 to that in 2004?
Provide a succinct answer. 1. What is the ratio of the Value added (constant 2005 US$) in Morocco in 2003 to that in 2004?
Offer a terse response. 0.96. What is the ratio of the Value added (constant 2005 US$) in Congo (Democratic) in 2003 to that in 2005?
Keep it short and to the point. 0.83. What is the ratio of the Value added (constant 2005 US$) of Cyprus in 2003 to that in 2005?
Make the answer very short. 0.96. What is the ratio of the Value added (constant 2005 US$) in Guyana in 2003 to that in 2005?
Make the answer very short. 1.06. What is the ratio of the Value added (constant 2005 US$) of Morocco in 2003 to that in 2005?
Your response must be concise. 0.92. What is the ratio of the Value added (constant 2005 US$) in Congo (Democratic) in 2003 to that in 2006?
Keep it short and to the point. 0.81. What is the ratio of the Value added (constant 2005 US$) of Cyprus in 2003 to that in 2006?
Your answer should be very brief. 0.92. What is the ratio of the Value added (constant 2005 US$) in Guyana in 2003 to that in 2006?
Provide a succinct answer. 0.93. What is the ratio of the Value added (constant 2005 US$) of Morocco in 2003 to that in 2006?
Your answer should be very brief. 0.88. What is the ratio of the Value added (constant 2005 US$) of Congo (Democratic) in 2003 to that in 2007?
Your answer should be compact. 0.77. What is the ratio of the Value added (constant 2005 US$) of Cyprus in 2003 to that in 2007?
Offer a very short reply. 0.87. What is the ratio of the Value added (constant 2005 US$) in Guyana in 2003 to that in 2007?
Give a very brief answer. 0.86. What is the ratio of the Value added (constant 2005 US$) in Morocco in 2003 to that in 2007?
Keep it short and to the point. 0.82. What is the ratio of the Value added (constant 2005 US$) in Congo (Democratic) in 2003 to that in 2008?
Ensure brevity in your answer.  0.74. What is the ratio of the Value added (constant 2005 US$) in Cyprus in 2003 to that in 2008?
Ensure brevity in your answer.  0.86. What is the ratio of the Value added (constant 2005 US$) of Guyana in 2003 to that in 2008?
Your response must be concise. 0.86. What is the ratio of the Value added (constant 2005 US$) of Morocco in 2003 to that in 2008?
Keep it short and to the point. 0.78. What is the ratio of the Value added (constant 2005 US$) of Congo (Democratic) in 2004 to that in 2005?
Your answer should be very brief. 0.88. What is the ratio of the Value added (constant 2005 US$) of Cyprus in 2004 to that in 2005?
Keep it short and to the point. 0.98. What is the ratio of the Value added (constant 2005 US$) of Guyana in 2004 to that in 2005?
Ensure brevity in your answer.  1.06. What is the ratio of the Value added (constant 2005 US$) of Morocco in 2004 to that in 2005?
Your answer should be compact. 0.95. What is the ratio of the Value added (constant 2005 US$) of Congo (Democratic) in 2004 to that in 2006?
Offer a terse response. 0.85. What is the ratio of the Value added (constant 2005 US$) of Cyprus in 2004 to that in 2006?
Offer a very short reply. 0.95. What is the ratio of the Value added (constant 2005 US$) in Morocco in 2004 to that in 2006?
Your response must be concise. 0.91. What is the ratio of the Value added (constant 2005 US$) of Congo (Democratic) in 2004 to that in 2007?
Give a very brief answer. 0.82. What is the ratio of the Value added (constant 2005 US$) in Cyprus in 2004 to that in 2007?
Your answer should be very brief. 0.9. What is the ratio of the Value added (constant 2005 US$) in Guyana in 2004 to that in 2007?
Give a very brief answer. 0.86. What is the ratio of the Value added (constant 2005 US$) in Morocco in 2004 to that in 2007?
Your answer should be compact. 0.85. What is the ratio of the Value added (constant 2005 US$) in Congo (Democratic) in 2004 to that in 2008?
Provide a short and direct response. 0.78. What is the ratio of the Value added (constant 2005 US$) in Cyprus in 2004 to that in 2008?
Give a very brief answer. 0.88. What is the ratio of the Value added (constant 2005 US$) in Guyana in 2004 to that in 2008?
Keep it short and to the point. 0.86. What is the ratio of the Value added (constant 2005 US$) of Morocco in 2004 to that in 2008?
Give a very brief answer. 0.81. What is the ratio of the Value added (constant 2005 US$) of Congo (Democratic) in 2005 to that in 2006?
Provide a succinct answer. 0.97. What is the ratio of the Value added (constant 2005 US$) of Cyprus in 2005 to that in 2006?
Make the answer very short. 0.97. What is the ratio of the Value added (constant 2005 US$) of Guyana in 2005 to that in 2006?
Provide a short and direct response. 0.88. What is the ratio of the Value added (constant 2005 US$) of Morocco in 2005 to that in 2006?
Ensure brevity in your answer.  0.95. What is the ratio of the Value added (constant 2005 US$) of Congo (Democratic) in 2005 to that in 2007?
Provide a short and direct response. 0.93. What is the ratio of the Value added (constant 2005 US$) in Cyprus in 2005 to that in 2007?
Provide a succinct answer. 0.91. What is the ratio of the Value added (constant 2005 US$) in Guyana in 2005 to that in 2007?
Provide a short and direct response. 0.81. What is the ratio of the Value added (constant 2005 US$) in Morocco in 2005 to that in 2007?
Offer a very short reply. 0.9. What is the ratio of the Value added (constant 2005 US$) in Congo (Democratic) in 2005 to that in 2008?
Ensure brevity in your answer.  0.89. What is the ratio of the Value added (constant 2005 US$) of Cyprus in 2005 to that in 2008?
Your response must be concise. 0.9. What is the ratio of the Value added (constant 2005 US$) of Guyana in 2005 to that in 2008?
Your answer should be very brief. 0.81. What is the ratio of the Value added (constant 2005 US$) of Morocco in 2005 to that in 2008?
Give a very brief answer. 0.85. What is the ratio of the Value added (constant 2005 US$) in Congo (Democratic) in 2006 to that in 2007?
Offer a terse response. 0.96. What is the ratio of the Value added (constant 2005 US$) in Cyprus in 2006 to that in 2007?
Give a very brief answer. 0.94. What is the ratio of the Value added (constant 2005 US$) of Guyana in 2006 to that in 2007?
Ensure brevity in your answer.  0.92. What is the ratio of the Value added (constant 2005 US$) in Morocco in 2006 to that in 2007?
Your response must be concise. 0.94. What is the ratio of the Value added (constant 2005 US$) of Congo (Democratic) in 2006 to that in 2008?
Your answer should be compact. 0.92. What is the ratio of the Value added (constant 2005 US$) in Cyprus in 2006 to that in 2008?
Your response must be concise. 0.93. What is the ratio of the Value added (constant 2005 US$) in Guyana in 2006 to that in 2008?
Your response must be concise. 0.92. What is the ratio of the Value added (constant 2005 US$) of Morocco in 2006 to that in 2008?
Make the answer very short. 0.89. What is the ratio of the Value added (constant 2005 US$) of Congo (Democratic) in 2007 to that in 2008?
Your answer should be very brief. 0.96. What is the ratio of the Value added (constant 2005 US$) of Cyprus in 2007 to that in 2008?
Your answer should be very brief. 0.98. What is the ratio of the Value added (constant 2005 US$) in Guyana in 2007 to that in 2008?
Provide a succinct answer. 1. What is the ratio of the Value added (constant 2005 US$) in Morocco in 2007 to that in 2008?
Ensure brevity in your answer.  0.94. What is the difference between the highest and the second highest Value added (constant 2005 US$) in Congo (Democratic)?
Your response must be concise. 1.81e+08. What is the difference between the highest and the second highest Value added (constant 2005 US$) in Cyprus?
Offer a very short reply. 6.15e+07. What is the difference between the highest and the second highest Value added (constant 2005 US$) of Guyana?
Your answer should be compact. 2.52e+05. What is the difference between the highest and the second highest Value added (constant 2005 US$) of Morocco?
Ensure brevity in your answer.  9.94e+08. What is the difference between the highest and the lowest Value added (constant 2005 US$) in Congo (Democratic)?
Your answer should be compact. 1.18e+09. What is the difference between the highest and the lowest Value added (constant 2005 US$) in Cyprus?
Keep it short and to the point. 7.05e+08. What is the difference between the highest and the lowest Value added (constant 2005 US$) in Guyana?
Your response must be concise. 3.24e+07. What is the difference between the highest and the lowest Value added (constant 2005 US$) of Morocco?
Your answer should be very brief. 4.57e+09. 